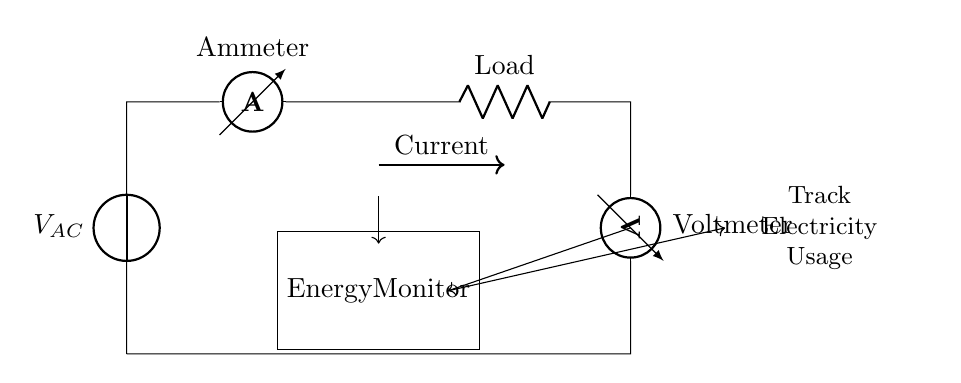What is the voltage source in this circuit? The circuit shows a voltage source labeled as V_AC, which indicates it is an alternating current source. This is the component providing the electrical energy for the circuit.
Answer: V_AC What type of meter is used to measure current? The circuit displays an ammeter, which is specifically designed to measure the flow of electrical current in the circuit. The label “Ammeter” indicates this clearly.
Answer: Ammeter What component is used to measure voltage? A voltmeter is depicted in the circuit and is connected across the load to measure the voltage drop across it. Its label “Voltmeter” confirms its function.
Answer: Voltmeter How many components are connected in series? The circuit has a total of four components connected in series: the voltage source, the ammeter, the load, and the voltmeter, which form a single path for current to flow.
Answer: Four What does the energy monitor do? The energy monitor is positioned in the circuit as a rectangle with the label “Energy Monitor”. It monitors energy usage, likely by calculating how much power is being consumed by the load based on current and voltage readings.
Answer: Track electricity usage If the current through the circuit is measured at 2 amperes, what can be inferred about current flow? Since this is a series circuit, the current remains the same throughout all components. Thus, if the ammeter reads 2 amperes, that current value applies to the entire circuit.
Answer: 2 amperes Why is the ammeter placed in series with the load? In series circuits, the ammeter must be placed in line with the components to accurately measure the same current that flows through the load. This placement allows for a correct reading of the total current.
Answer: To measure current accurately 